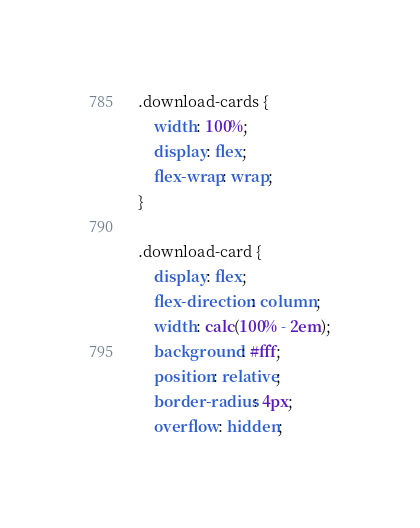<code> <loc_0><loc_0><loc_500><loc_500><_CSS_>.download-cards {
    width: 100%;
    display: flex;
    flex-wrap: wrap;
}

.download-card {
    display: flex;
    flex-direction: column;
    width: calc(100% - 2em);
    background: #fff;
    position: relative;
    border-radius: 4px;
    overflow: hidden;</code> 